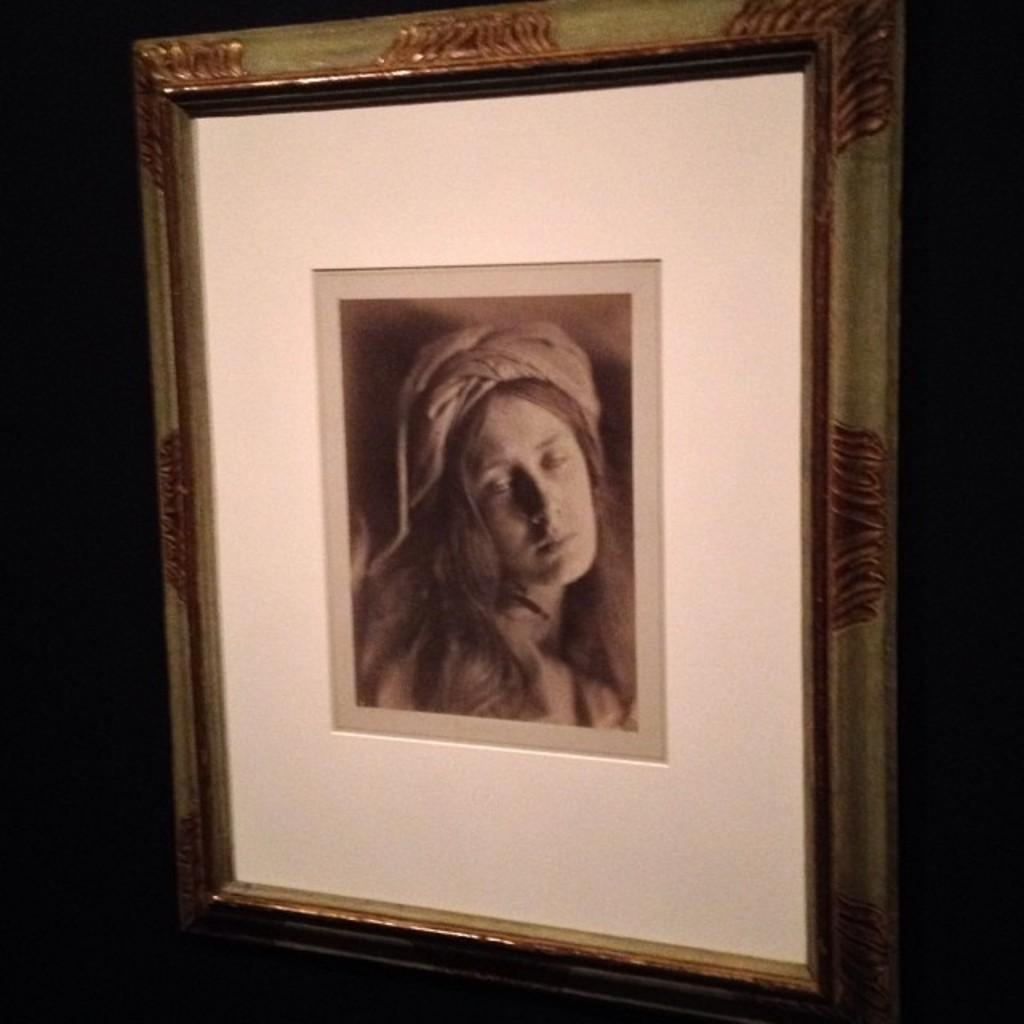Please provide a concise description of this image. In this picture we can see a photo frame, in the photo frame we can find a woman photograph. 